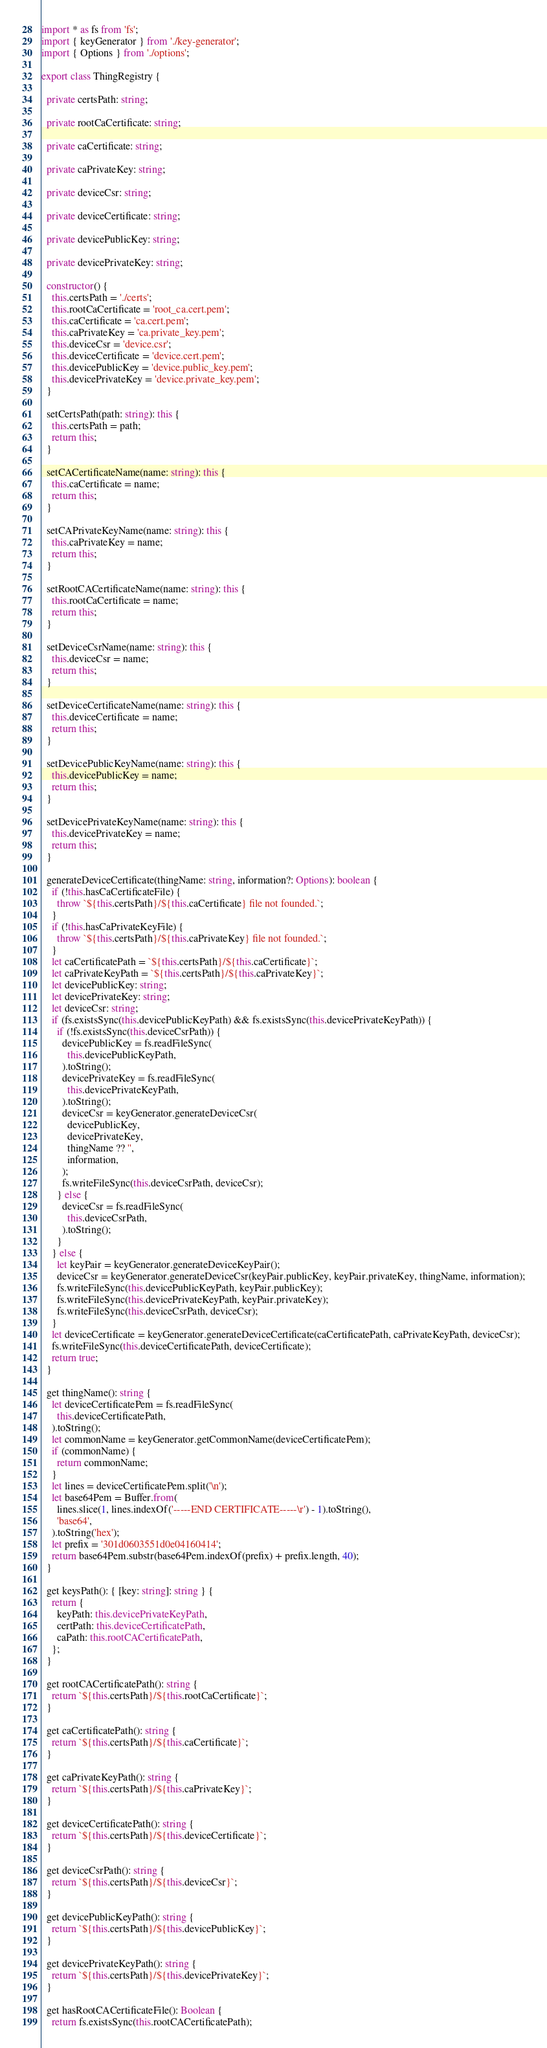<code> <loc_0><loc_0><loc_500><loc_500><_TypeScript_>import * as fs from 'fs';
import { keyGenerator } from './key-generator';
import { Options } from './options';

export class ThingRegistry {

  private certsPath: string;

  private rootCaCertificate: string;

  private caCertificate: string;

  private caPrivateKey: string;

  private deviceCsr: string;

  private deviceCertificate: string;

  private devicePublicKey: string;

  private devicePrivateKey: string;

  constructor() {
    this.certsPath = './certs';
    this.rootCaCertificate = 'root_ca.cert.pem';
    this.caCertificate = 'ca.cert.pem';
    this.caPrivateKey = 'ca.private_key.pem';
    this.deviceCsr = 'device.csr';
    this.deviceCertificate = 'device.cert.pem';
    this.devicePublicKey = 'device.public_key.pem';
    this.devicePrivateKey = 'device.private_key.pem';
  }

  setCertsPath(path: string): this {
    this.certsPath = path;
    return this;
  }

  setCACertificateName(name: string): this {
    this.caCertificate = name;
    return this;
  }

  setCAPrivateKeyName(name: string): this {
    this.caPrivateKey = name;
    return this;
  }

  setRootCACertificateName(name: string): this {
    this.rootCaCertificate = name;
    return this;
  }

  setDeviceCsrName(name: string): this {
    this.deviceCsr = name;
    return this;
  }

  setDeviceCertificateName(name: string): this {
    this.deviceCertificate = name;
    return this;
  }

  setDevicePublicKeyName(name: string): this {
    this.devicePublicKey = name;
    return this;
  }

  setDevicePrivateKeyName(name: string): this {
    this.devicePrivateKey = name;
    return this;
  }

  generateDeviceCertificate(thingName: string, information?: Options): boolean {
    if (!this.hasCaCertificateFile) {
      throw `${this.certsPath}/${this.caCertificate} file not founded.`;
    }
    if (!this.hasCaPrivateKeyFile) {
      throw `${this.certsPath}/${this.caPrivateKey} file not founded.`;
    }
    let caCertificatePath = `${this.certsPath}/${this.caCertificate}`;
    let caPrivateKeyPath = `${this.certsPath}/${this.caPrivateKey}`;
    let devicePublicKey: string;
    let devicePrivateKey: string;
    let deviceCsr: string;
    if (fs.existsSync(this.devicePublicKeyPath) && fs.existsSync(this.devicePrivateKeyPath)) {
      if (!fs.existsSync(this.deviceCsrPath)) {
        devicePublicKey = fs.readFileSync(
          this.devicePublicKeyPath,
        ).toString();
        devicePrivateKey = fs.readFileSync(
          this.devicePrivateKeyPath,
        ).toString();
        deviceCsr = keyGenerator.generateDeviceCsr(
          devicePublicKey,
          devicePrivateKey,
          thingName ?? '',
          information,
        );
        fs.writeFileSync(this.deviceCsrPath, deviceCsr);
      } else {
        deviceCsr = fs.readFileSync(
          this.deviceCsrPath,
        ).toString();
      }
    } else {
      let keyPair = keyGenerator.generateDeviceKeyPair();
      deviceCsr = keyGenerator.generateDeviceCsr(keyPair.publicKey, keyPair.privateKey, thingName, information);
      fs.writeFileSync(this.devicePublicKeyPath, keyPair.publicKey);
      fs.writeFileSync(this.devicePrivateKeyPath, keyPair.privateKey);
      fs.writeFileSync(this.deviceCsrPath, deviceCsr);
    }
    let deviceCertificate = keyGenerator.generateDeviceCertificate(caCertificatePath, caPrivateKeyPath, deviceCsr);
    fs.writeFileSync(this.deviceCertificatePath, deviceCertificate);
    return true;
  }

  get thingName(): string {
    let deviceCertificatePem = fs.readFileSync(
      this.deviceCertificatePath,
    ).toString();
    let commonName = keyGenerator.getCommonName(deviceCertificatePem);
    if (commonName) {
      return commonName;
    }
    let lines = deviceCertificatePem.split('\n');
    let base64Pem = Buffer.from(
      lines.slice(1, lines.indexOf('-----END CERTIFICATE-----\r') - 1).toString(),
      'base64',
    ).toString('hex');
    let prefix = '301d0603551d0e04160414';
    return base64Pem.substr(base64Pem.indexOf(prefix) + prefix.length, 40);
  }

  get keysPath(): { [key: string]: string } {
    return {
      keyPath: this.devicePrivateKeyPath,
      certPath: this.deviceCertificatePath,
      caPath: this.rootCACertificatePath,
    };
  }

  get rootCACertificatePath(): string {
    return `${this.certsPath}/${this.rootCaCertificate}`;
  }

  get caCertificatePath(): string {
    return `${this.certsPath}/${this.caCertificate}`;
  }

  get caPrivateKeyPath(): string {
    return `${this.certsPath}/${this.caPrivateKey}`;
  }

  get deviceCertificatePath(): string {
    return `${this.certsPath}/${this.deviceCertificate}`;
  }

  get deviceCsrPath(): string {
    return `${this.certsPath}/${this.deviceCsr}`;
  }

  get devicePublicKeyPath(): string {
    return `${this.certsPath}/${this.devicePublicKey}`;
  }

  get devicePrivateKeyPath(): string {
    return `${this.certsPath}/${this.devicePrivateKey}`;
  }

  get hasRootCACertificateFile(): Boolean {
    return fs.existsSync(this.rootCACertificatePath);</code> 